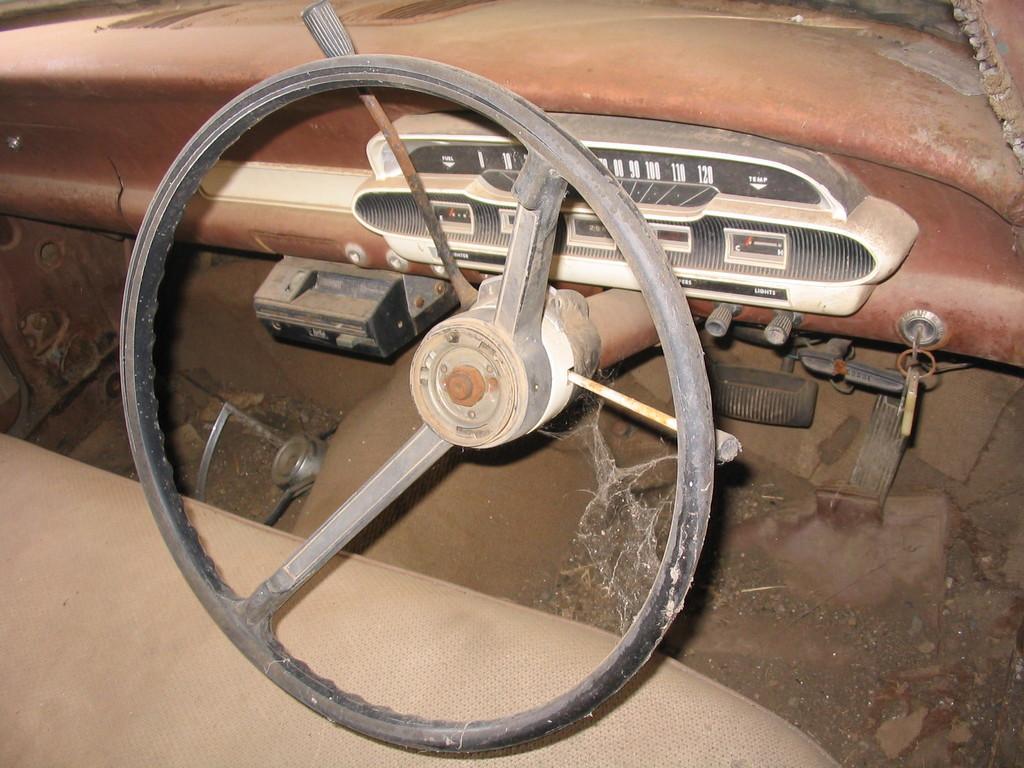Could you give a brief overview of what you see in this image? In this image, we can see the inside view of the vehicle. Here there is a steering, few boxes, buttons, keys, rods, seat. Here we can see a web. 